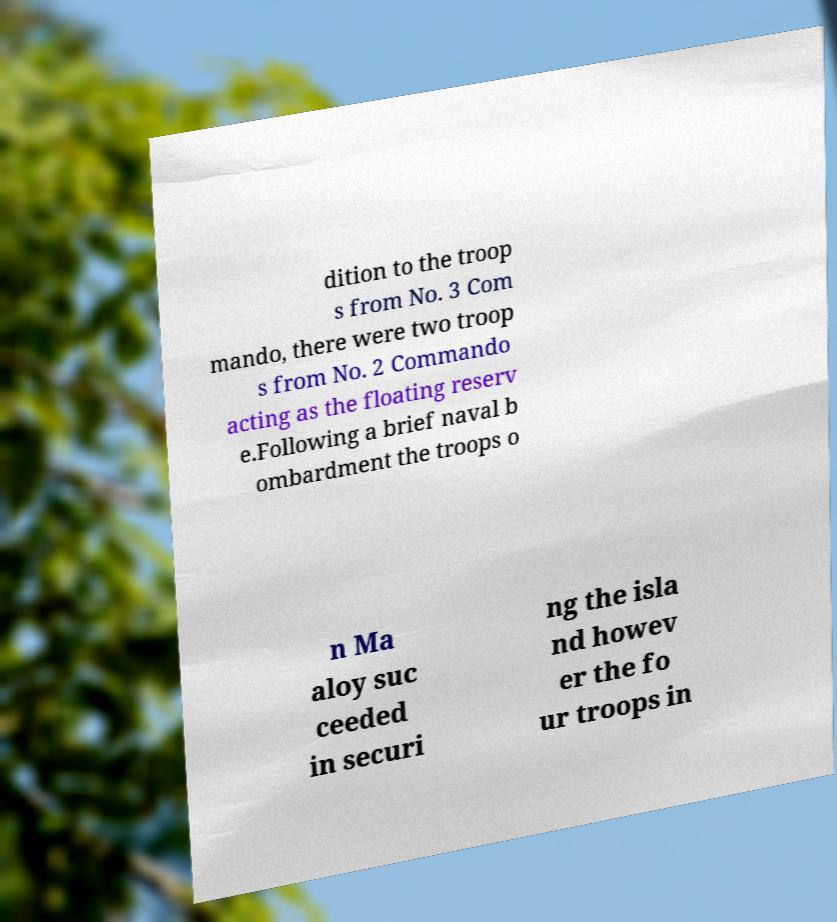Can you read and provide the text displayed in the image?This photo seems to have some interesting text. Can you extract and type it out for me? dition to the troop s from No. 3 Com mando, there were two troop s from No. 2 Commando acting as the floating reserv e.Following a brief naval b ombardment the troops o n Ma aloy suc ceeded in securi ng the isla nd howev er the fo ur troops in 